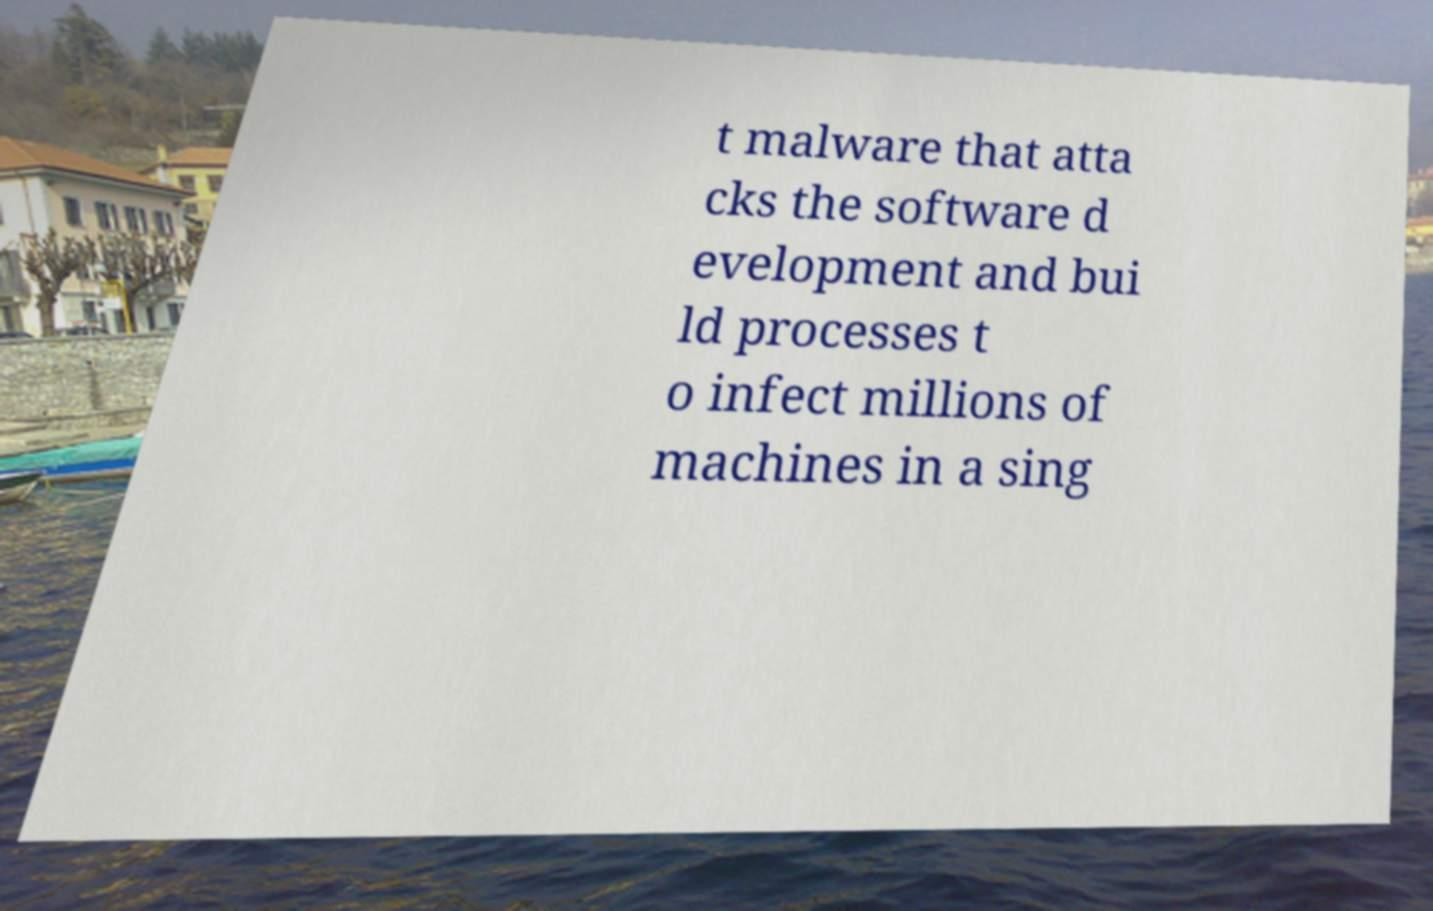Can you read and provide the text displayed in the image?This photo seems to have some interesting text. Can you extract and type it out for me? t malware that atta cks the software d evelopment and bui ld processes t o infect millions of machines in a sing 